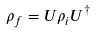<formula> <loc_0><loc_0><loc_500><loc_500>\rho _ { f } = U \rho _ { i } U ^ { \dag }</formula> 